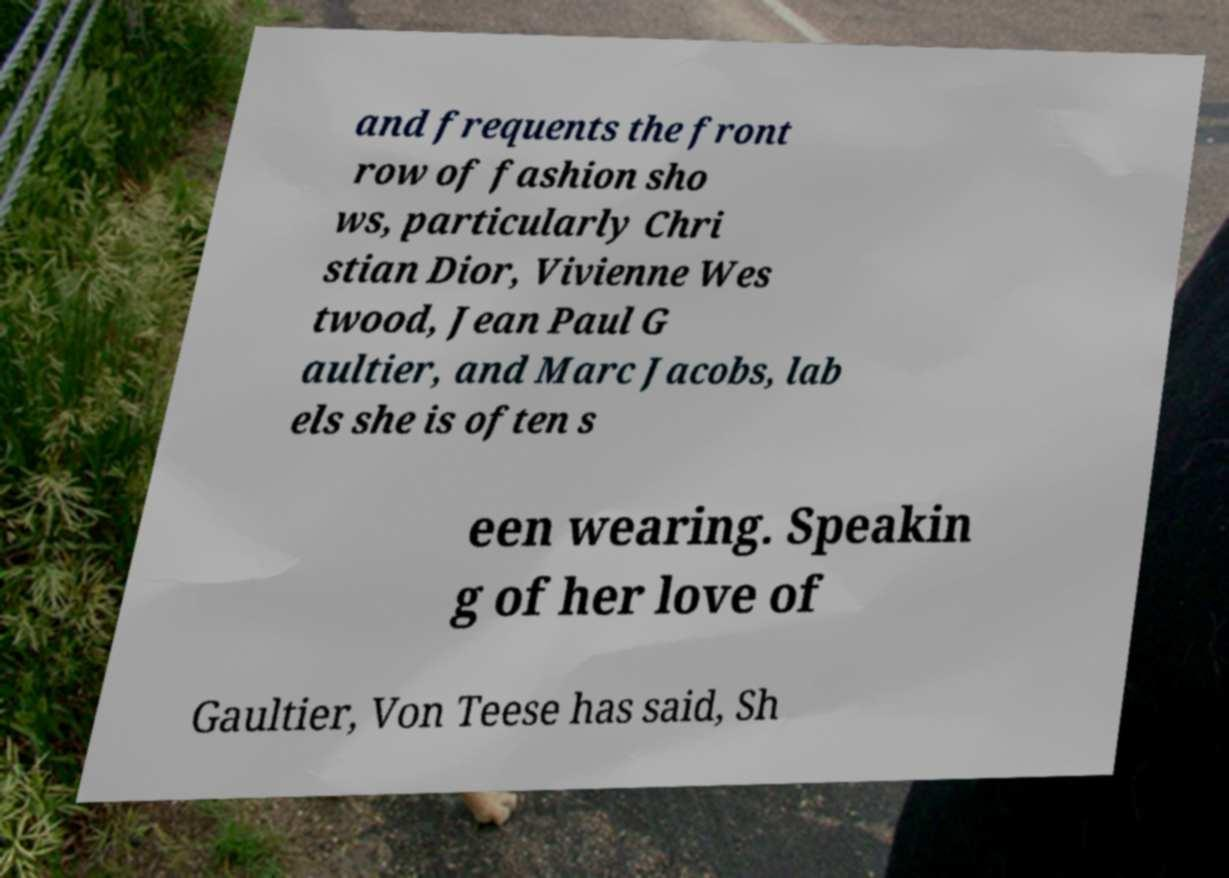Please identify and transcribe the text found in this image. and frequents the front row of fashion sho ws, particularly Chri stian Dior, Vivienne Wes twood, Jean Paul G aultier, and Marc Jacobs, lab els she is often s een wearing. Speakin g of her love of Gaultier, Von Teese has said, Sh 